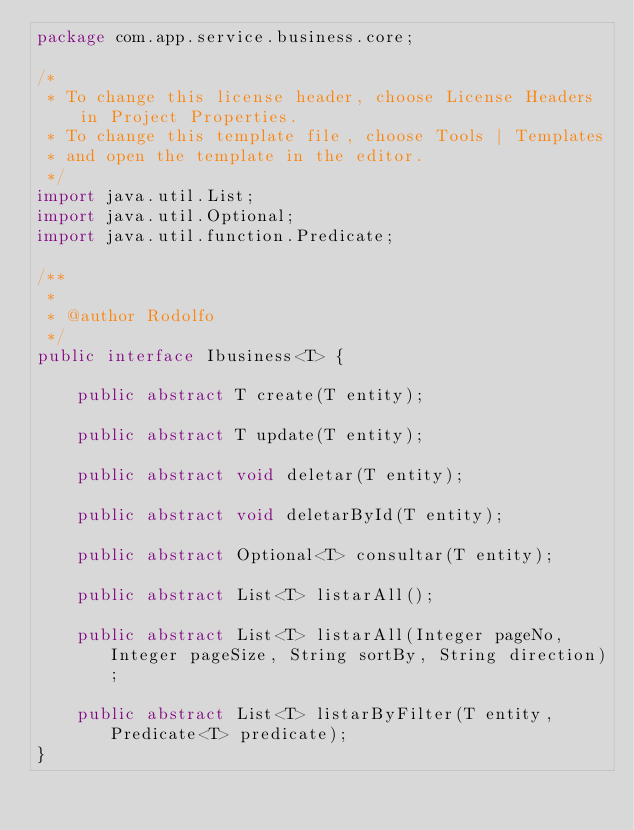Convert code to text. <code><loc_0><loc_0><loc_500><loc_500><_Java_>package com.app.service.business.core;

/*
 * To change this license header, choose License Headers in Project Properties.
 * To change this template file, choose Tools | Templates
 * and open the template in the editor.
 */
import java.util.List;
import java.util.Optional;
import java.util.function.Predicate;

/**
 *
 * @author Rodolfo
 */
public interface Ibusiness<T> {

    public abstract T create(T entity);

    public abstract T update(T entity);

    public abstract void deletar(T entity);

    public abstract void deletarById(T entity);

    public abstract Optional<T> consultar(T entity);

    public abstract List<T> listarAll();

    public abstract List<T> listarAll(Integer pageNo, Integer pageSize, String sortBy, String direction);

    public abstract List<T> listarByFilter(T entity, Predicate<T> predicate);
}
</code> 